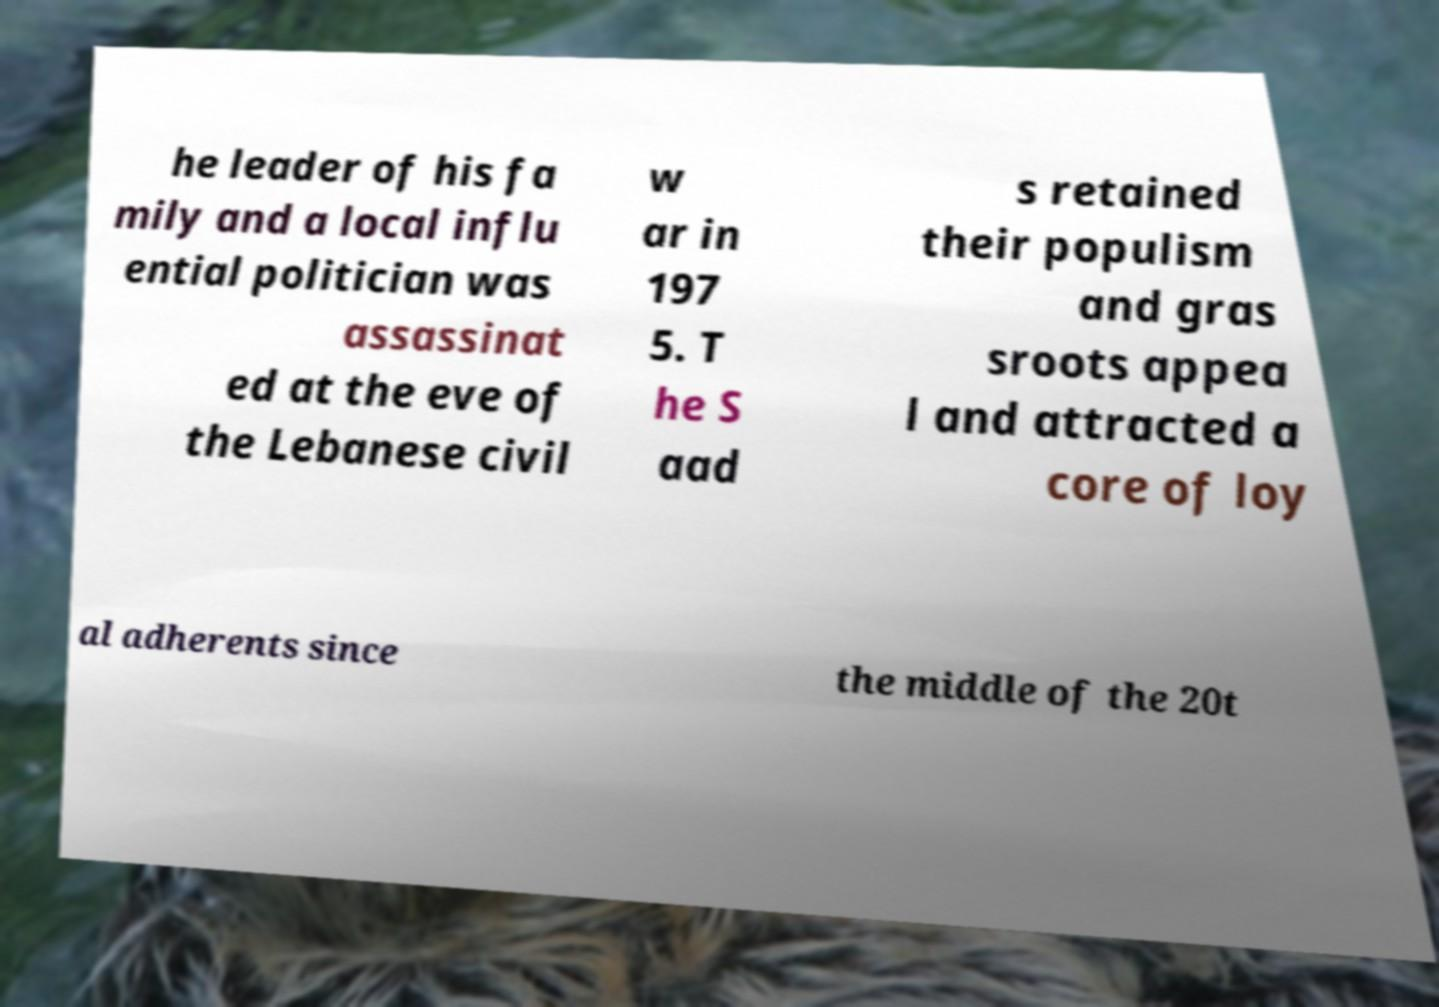For documentation purposes, I need the text within this image transcribed. Could you provide that? he leader of his fa mily and a local influ ential politician was assassinat ed at the eve of the Lebanese civil w ar in 197 5. T he S aad s retained their populism and gras sroots appea l and attracted a core of loy al adherents since the middle of the 20t 